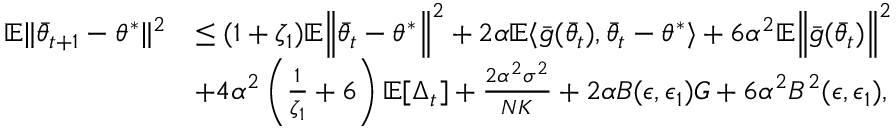<formula> <loc_0><loc_0><loc_500><loc_500>\begin{array} { r l } { \mathbb { E } \| \bar { \theta } _ { t + 1 } - \theta ^ { * } \| ^ { 2 } } & { \leq ( 1 + \zeta _ { 1 } ) \mathbb { E } \left \| \bar { \theta } _ { t } - \theta ^ { * } \right \| ^ { 2 } + 2 \alpha \mathbb { E } \langle \bar { g } ( \bar { \theta } _ { t } ) , \bar { \theta } _ { t } - \theta ^ { * } \rangle + 6 \alpha ^ { 2 } \mathbb { E } \left \| \bar { g } ( \bar { \theta } _ { t } ) \right \| ^ { 2 } } \\ & { + 4 \alpha ^ { 2 } \left ( \frac { 1 } { \zeta _ { 1 } } + 6 \right ) \mathbb { E } [ \Delta _ { t } ] + \frac { 2 \alpha ^ { 2 } \sigma ^ { 2 } } { N K } + 2 \alpha B ( \epsilon , \epsilon _ { 1 } ) G + 6 \alpha ^ { 2 } B ^ { 2 } ( \epsilon , \epsilon _ { 1 } ) , } \end{array}</formula> 